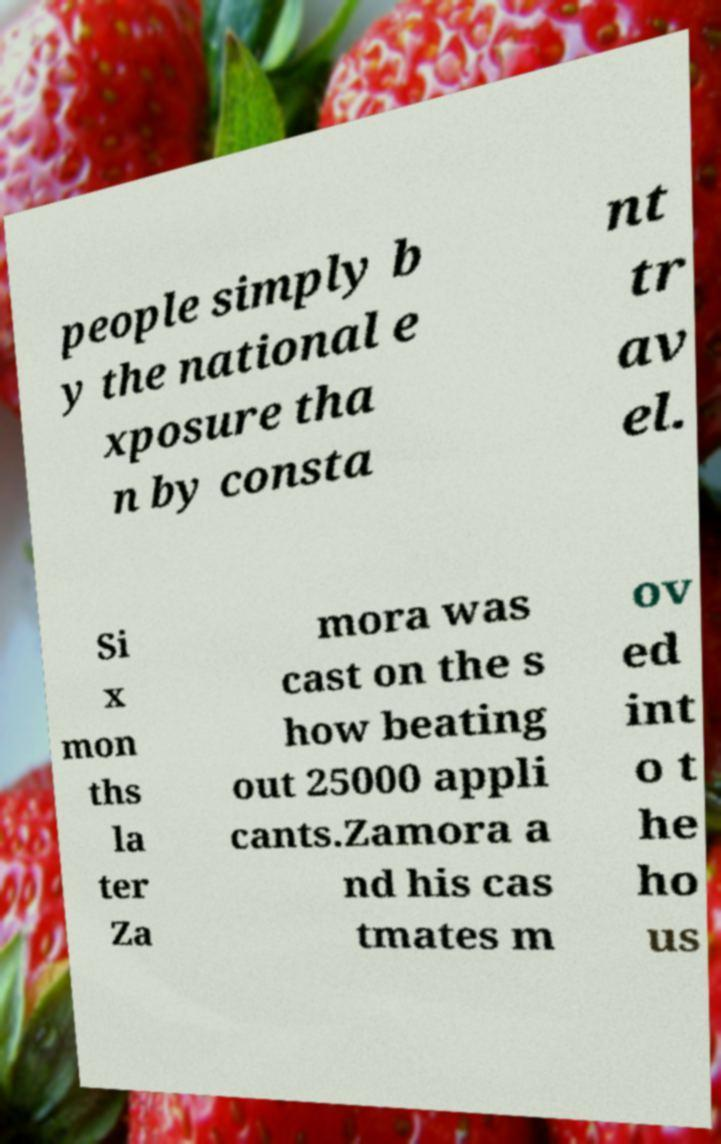Can you read and provide the text displayed in the image?This photo seems to have some interesting text. Can you extract and type it out for me? people simply b y the national e xposure tha n by consta nt tr av el. Si x mon ths la ter Za mora was cast on the s how beating out 25000 appli cants.Zamora a nd his cas tmates m ov ed int o t he ho us 